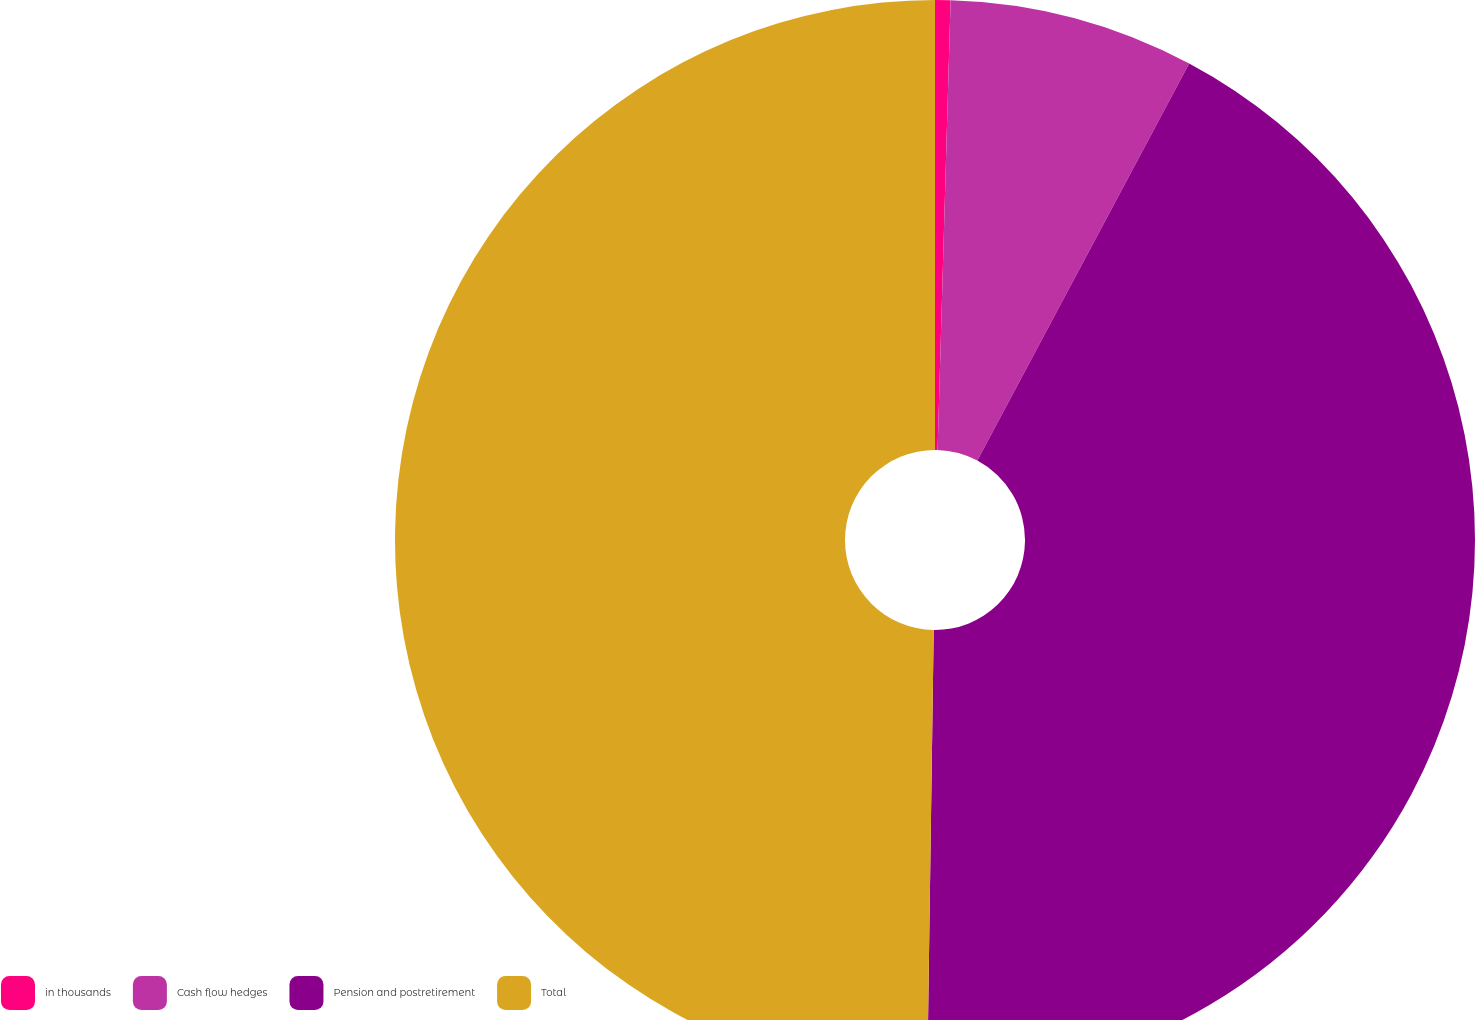<chart> <loc_0><loc_0><loc_500><loc_500><pie_chart><fcel>in thousands<fcel>Cash flow hedges<fcel>Pension and postretirement<fcel>Total<nl><fcel>0.46%<fcel>7.34%<fcel>42.43%<fcel>49.77%<nl></chart> 